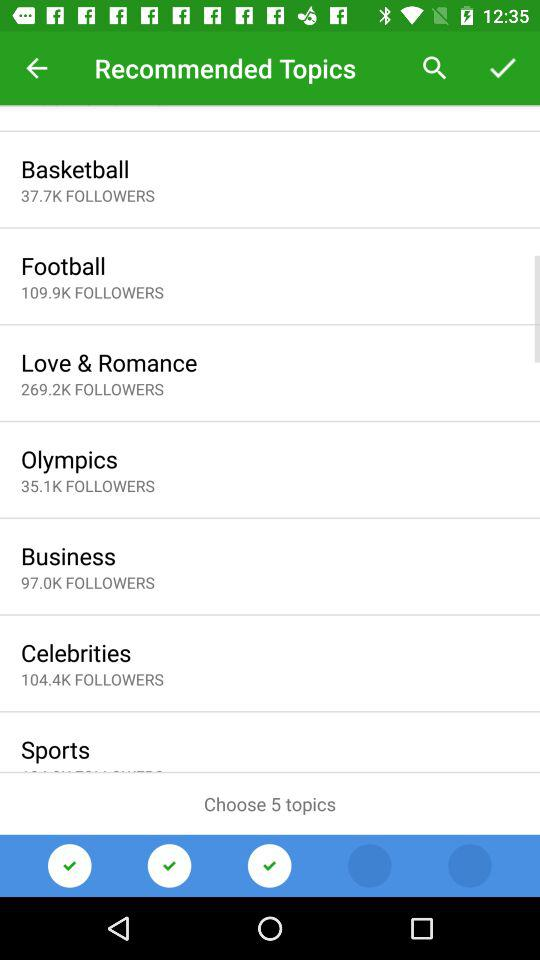How many followers of basketball are there? There are 37.7K followers of basketball. 